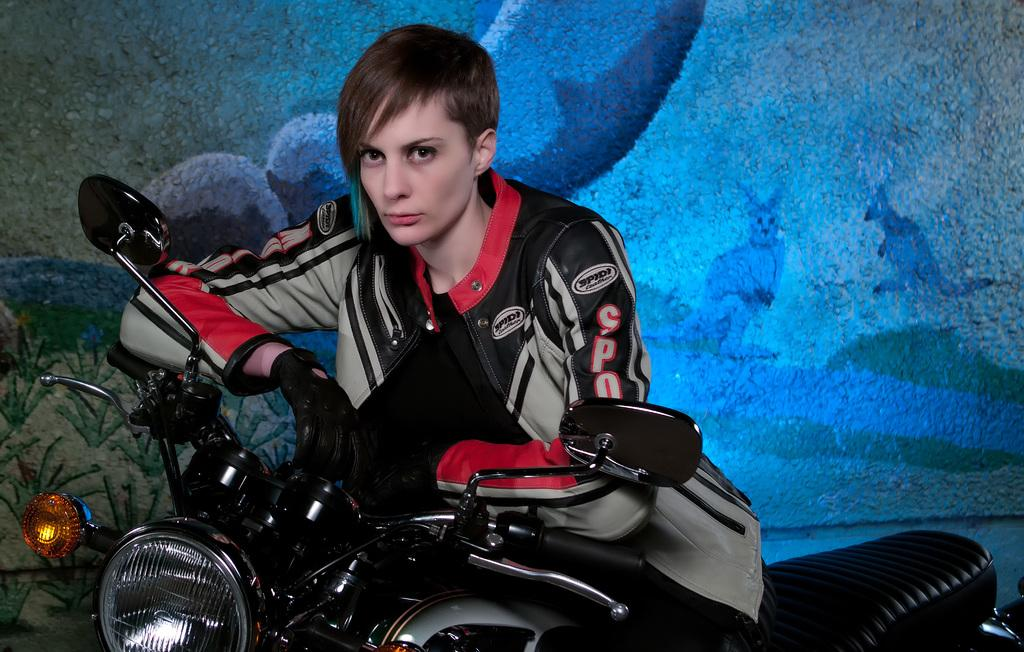What is the person in the image doing? The person is sitting on a bike in the image. What can be seen on the wall in the image? There is a painting on the wall in the image. What letter is the person on the bike trying to write in the image? There is no letter present in the image; the person is simply sitting on a bike. 